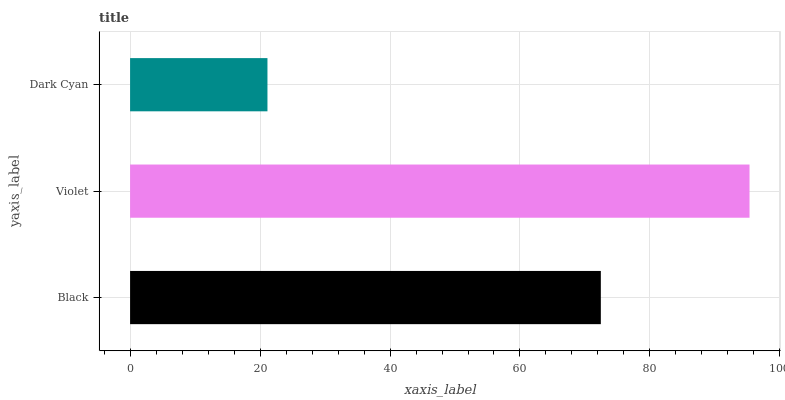Is Dark Cyan the minimum?
Answer yes or no. Yes. Is Violet the maximum?
Answer yes or no. Yes. Is Violet the minimum?
Answer yes or no. No. Is Dark Cyan the maximum?
Answer yes or no. No. Is Violet greater than Dark Cyan?
Answer yes or no. Yes. Is Dark Cyan less than Violet?
Answer yes or no. Yes. Is Dark Cyan greater than Violet?
Answer yes or no. No. Is Violet less than Dark Cyan?
Answer yes or no. No. Is Black the high median?
Answer yes or no. Yes. Is Black the low median?
Answer yes or no. Yes. Is Dark Cyan the high median?
Answer yes or no. No. Is Violet the low median?
Answer yes or no. No. 